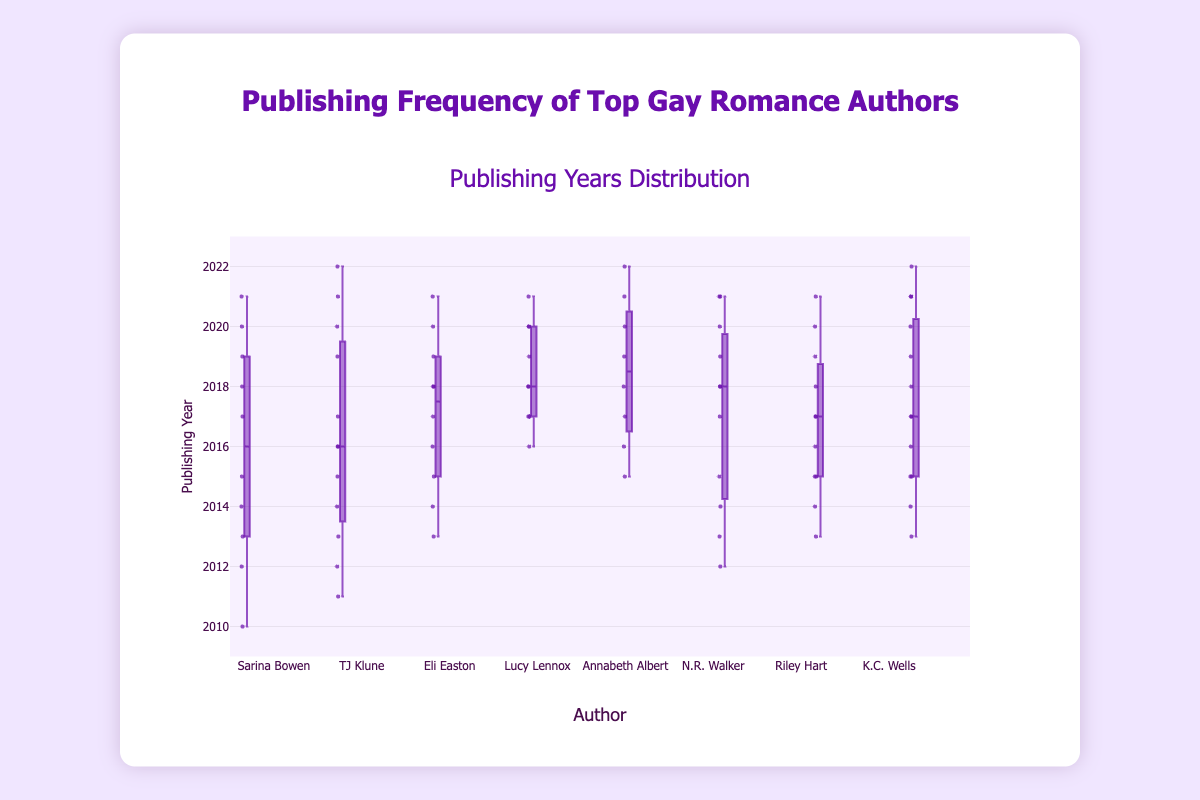How many years did Eli Easton publish books according to the data? Eli Easton has years of publishing listed from 2013 to 2021, with multiple entries for some years, resulting in a count of 10.
Answer: 10 Which author started publishing earliest according to the figure? According to the data, Sarina Bowen started publishing in 2010, making her the earliest among the listed authors.
Answer: Sarina Bowen What is the median publishing year for Annabeth Albert? To find the median, list the years Annabeth Albert published sorted: [2015, 2016, 2017, 2018, 2019, 2020, 2021, 2022]. With 8 years, the median is the average of the 4th and 5th values: (2018 + 2019)/2 = 2018.5.
Answer: 2018.5 Which author has the most entries in the box plot? By counting the number of entries for each author, K.C. Wells has the most entries with a total of 13 publishing years.
Answer: K.C. Wells Who published more frequently in the year 2017, Lucy Lennox or Riley Hart? Lucy Lennox has 2 entries in 2017, and Riley Hart also has 2 entries in 2017, making their publishing frequencies equal for that year.
Answer: Same frequency What is the range of publishing years for TJ Klune? The range can be calculated by subtracting the earliest year (2011) from the latest year (2022), giving 2022 - 2011 = 11 years.
Answer: 11 years Which author has the smallest spread in their publishing years? By visually inspecting the box plots, Annabeth Albert's boxplot appears the smallest in terms of the range of years, indicating she has the smallest spread.
Answer: Annabeth Albert Is there any year where Sarina Bowen and N.R. Walker both published books? Both Sarina Bowen and N.R. Walker published books in the years 2012, 2013, 2014, 2015, 2017, 2018, 2019, 2020, and 2021.
Answer: Yes Compared to K.C. Wells, how concentrated are Riley Hart's publishing years? K.C. Wells has publishing years spread from 2013 to 2022, while Riley Hart's are from 2013 to 2021. Given K.C. Wells has more data points and a broader range, Riley Hart's publishing years are relatively more concentrated.
Answer: More concentrated 